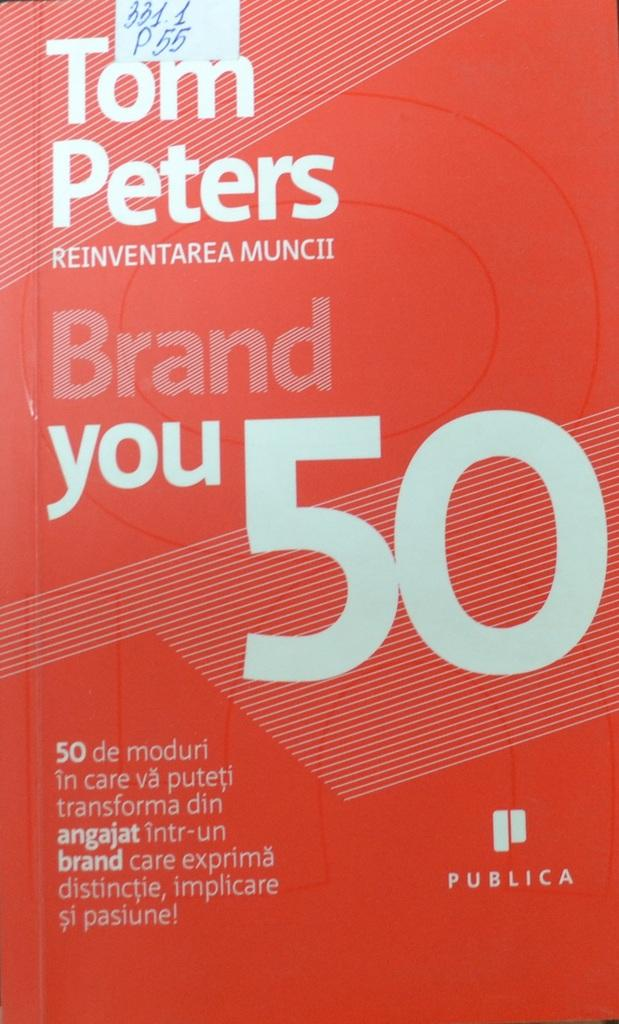<image>
Render a clear and concise summary of the photo. A red book titled Brand You 50 with writing in a foreign language on it. 